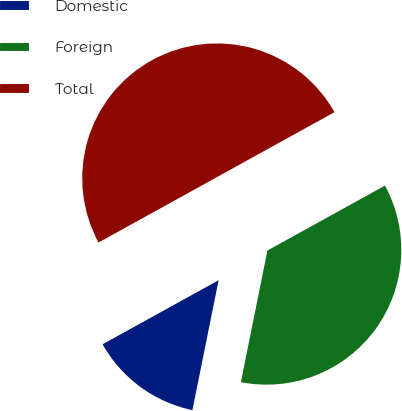<chart> <loc_0><loc_0><loc_500><loc_500><pie_chart><fcel>Domestic<fcel>Foreign<fcel>Total<nl><fcel>13.8%<fcel>36.2%<fcel>50.0%<nl></chart> 